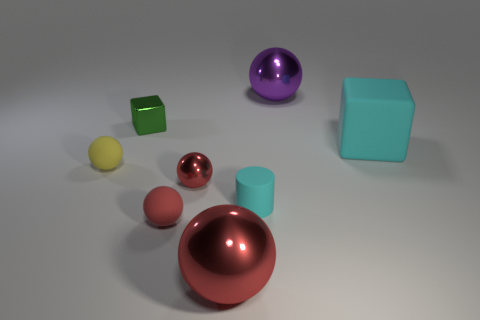Is the color of the big cube the same as the tiny metallic ball?
Ensure brevity in your answer.  No. Is there a purple metallic sphere that has the same size as the green block?
Provide a short and direct response. No. Do the tiny metal ball and the big shiny ball in front of the large matte object have the same color?
Keep it short and to the point. Yes. What material is the small yellow ball?
Provide a succinct answer. Rubber. What is the color of the large metallic object in front of the small red matte sphere?
Offer a terse response. Red. How many big rubber cubes are the same color as the tiny cylinder?
Make the answer very short. 1. How many rubber spheres are both left of the small green thing and to the right of the tiny yellow thing?
Give a very brief answer. 0. There is a purple object that is the same size as the cyan matte cube; what shape is it?
Offer a terse response. Sphere. The red matte object is what size?
Offer a terse response. Small. What material is the large sphere that is behind the small thing behind the big block in front of the purple metal object made of?
Keep it short and to the point. Metal. 